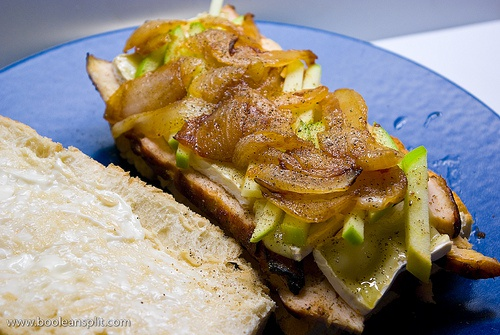Describe the objects in this image and their specific colors. I can see dining table in lightgray, darkgray, black, olive, and tan tones, sandwich in gray, lightgray, olive, and tan tones, dining table in gray, darkgray, black, and blue tones, apple in gray, tan, and olive tones, and apple in gray, olive, and khaki tones in this image. 